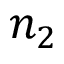Convert formula to latex. <formula><loc_0><loc_0><loc_500><loc_500>n _ { 2 }</formula> 